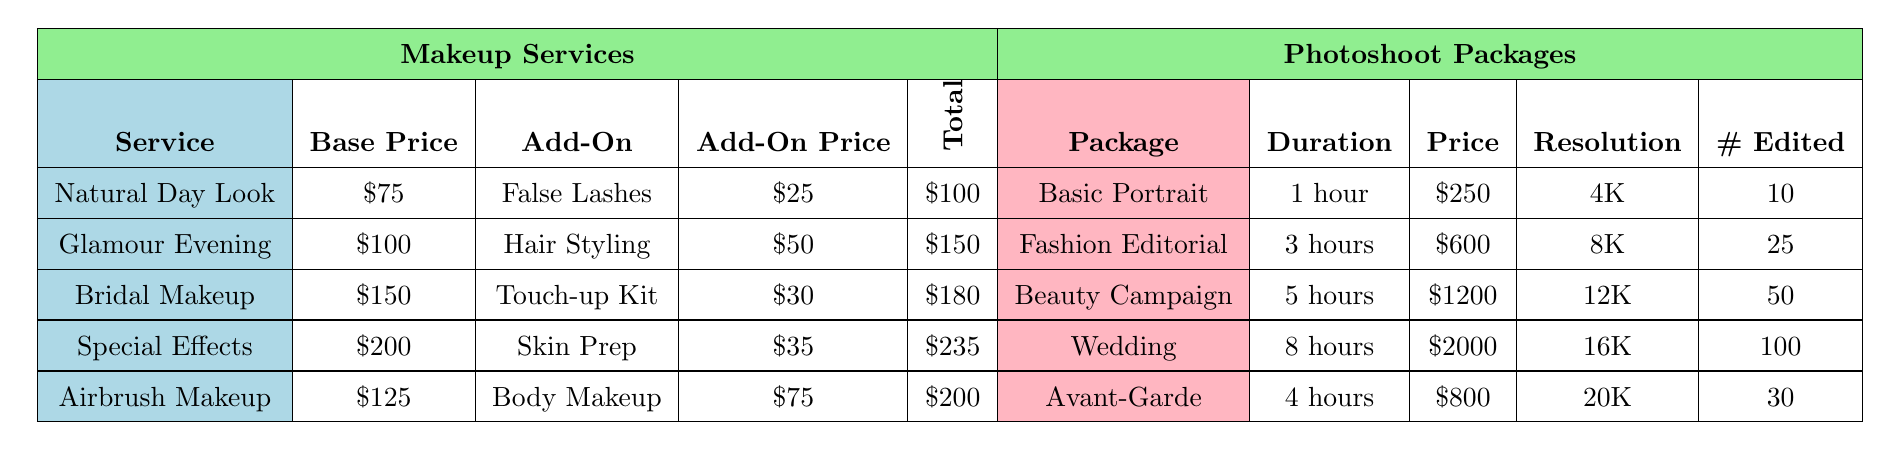What is the base price of Bridal Makeup? The base price for Bridal Makeup is listed directly in the table under the "Base Price" column, next to "Bridal Makeup." It shows $150.
Answer: $150 What is the total cost for a Glamour Evening Look with False Lashes? The total cost is the sum of the base price and the add-on price for Glamour Evening Look. The base price is $100 and the add-on price for False Lashes is $25. Thus, total is $100 + $25 = $125.
Answer: $125 Which photoshoot package has the highest price? The prices for the photoshoot packages are compared. Wedding has the highest price at $2000, followed by Beauty Campaign at $1200. Therefore, Wedding is the highest.
Answer: Wedding How many edited images are included in the Beauty Campaign package? The number of edited images for the Beauty Campaign package is directly stated in the table, which indicates 50 edited images.
Answer: 50 Is there an add-on available for the Airbrush Makeup service? Yes, the table states that Body Makeup is an add-on for Airbrush Makeup, indicating that there is an available add-on.
Answer: Yes What is the average duration of the photoshoot packages? To find the average, convert the durations to hours: 1, 3, 5, 8, and 4. The total is 1 + 3 + 5 + 8 + 4 = 21. There are 5 packages, so the average duration is 21/5 = 4.2 hours.
Answer: 4.2 hours What is the difference in price between the Special Effects Makeup and the Bridal Makeup? The price for Special Effects Makeup is $200, and for Bridal Makeup it is $150. The difference is $200 - $150 = $50.
Answer: $50 How many hours of duration does the Avant-Garde photoshoot package offer? The table indicates that the duration for Avant-Garde is listed as 4 hours, directly in the "Duration" column.
Answer: 4 hours Which makeup service has the same add-on price as Airbrush Makeup? The add-on price for Airbrush Makeup is $75. By checking the add-on prices, we see the only matching price is for Body Makeup. Thus, there is no other service with the same add-on price.
Answer: None What is the total cost of the Bridal Makeup package if the Touch-up Kit is added? The total cost for Bridal Makeup is the base price $150 plus the add-on price for Touch-up Kit, which is $30. So, $150 + $30 = $180.
Answer: $180 Which photoshoot package can be completed in 1 hour? The table lists the Basic Portrait as the only photoshoot package that takes 1 hour, directly indicated in the "Duration" column.
Answer: Basic Portrait 